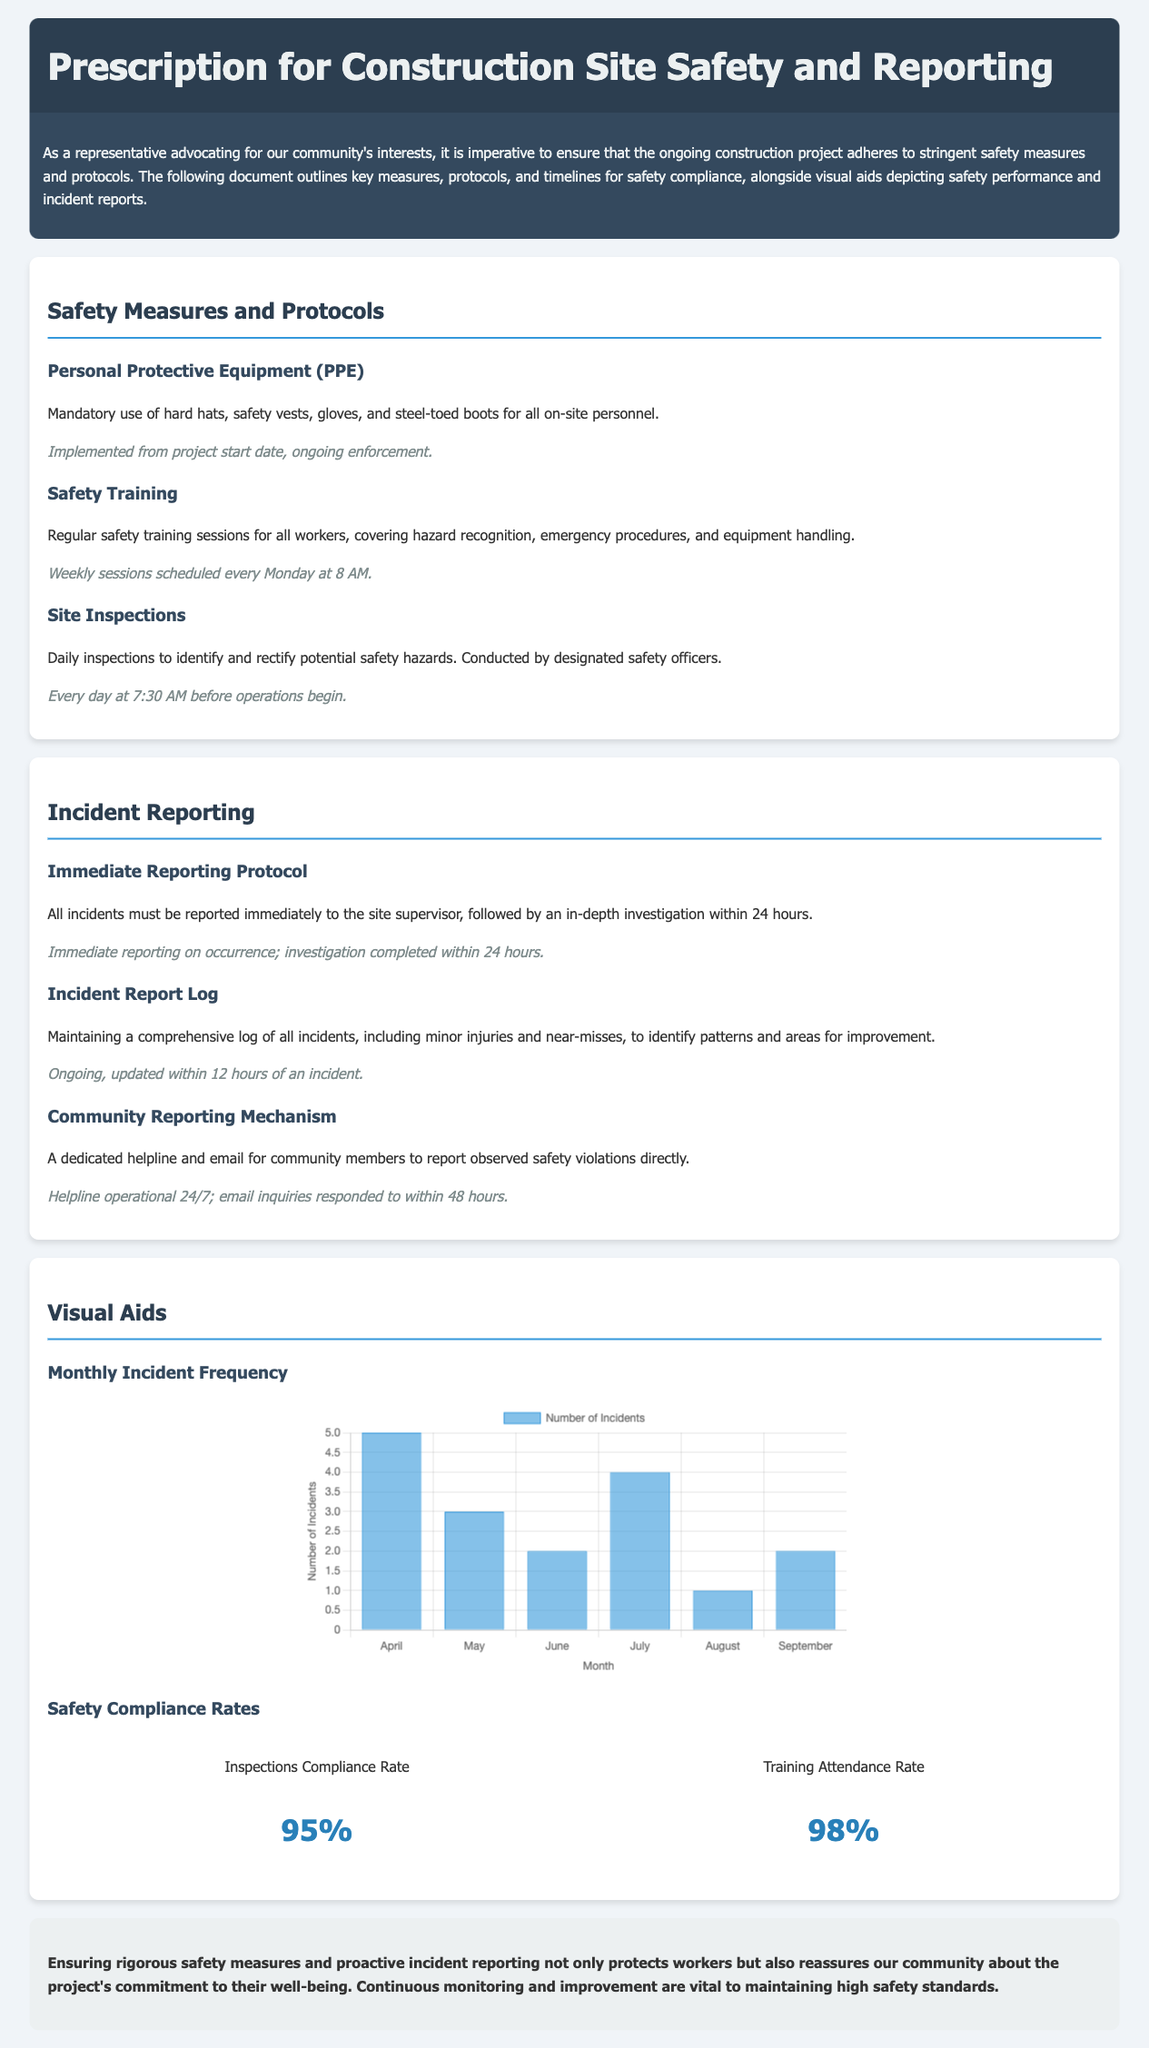What is the mandatory personal protective equipment? The section on Personal Protective Equipment specifies the items required for all on-site personnel.
Answer: hard hats, safety vests, gloves, and steel-toed boots When are safety training sessions scheduled? The document states that safety training sessions are held at a specific time every week.
Answer: every Monday at 8 AM What is the inspections compliance rate? The infographic lists the compliance rate for site inspections.
Answer: 95% What is the frequency of incident log updates? The section on Incident Report Log mentions how often the log should be updated following an incident.
Answer: within 12 hours How many incidents were reported in April? The Monthly Incident Frequency chart shows the number of incidents per month, specifically for April.
Answer: 5 What time do daily site inspections occur? The document outlines when daily inspections are conducted by safety officers.
Answer: 7:30 AM How many training sessions are conducted weekly? The section on Safety Training notes how frequently these sessions are held.
Answer: weekly What is the response time for community email inquiries? The Community Reporting Mechanism section indicates how quickly email inquiries should be addressed.
Answer: within 48 hours 